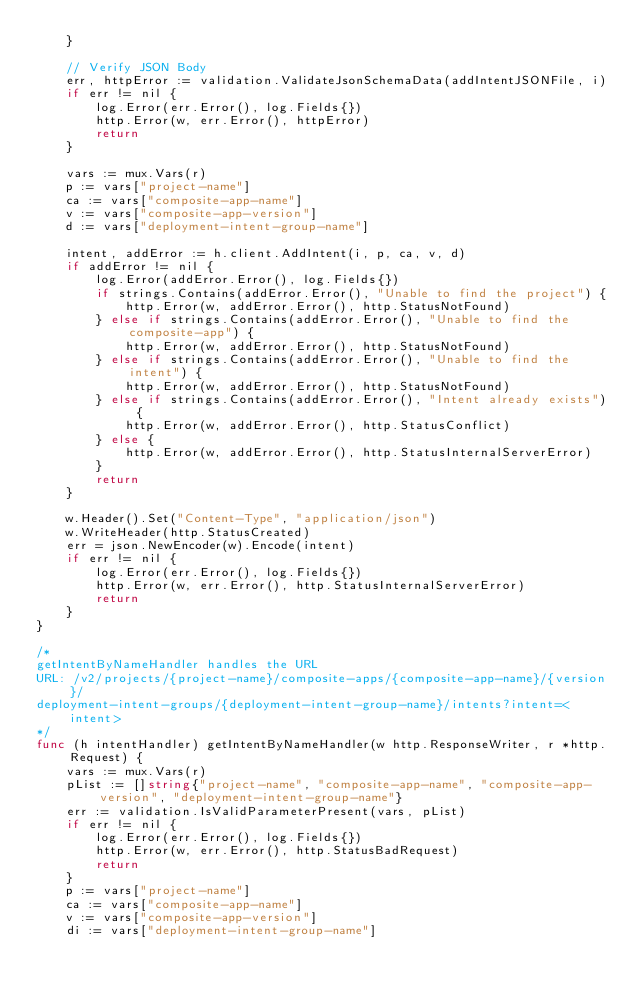<code> <loc_0><loc_0><loc_500><loc_500><_Go_>	}

	// Verify JSON Body
	err, httpError := validation.ValidateJsonSchemaData(addIntentJSONFile, i)
	if err != nil {
		log.Error(err.Error(), log.Fields{})
		http.Error(w, err.Error(), httpError)
		return
	}

	vars := mux.Vars(r)
	p := vars["project-name"]
	ca := vars["composite-app-name"]
	v := vars["composite-app-version"]
	d := vars["deployment-intent-group-name"]

	intent, addError := h.client.AddIntent(i, p, ca, v, d)
	if addError != nil {
		log.Error(addError.Error(), log.Fields{})
		if strings.Contains(addError.Error(), "Unable to find the project") {
			http.Error(w, addError.Error(), http.StatusNotFound)
		} else if strings.Contains(addError.Error(), "Unable to find the composite-app") {
			http.Error(w, addError.Error(), http.StatusNotFound)
		} else if strings.Contains(addError.Error(), "Unable to find the intent") {
			http.Error(w, addError.Error(), http.StatusNotFound)
		} else if strings.Contains(addError.Error(), "Intent already exists") {
			http.Error(w, addError.Error(), http.StatusConflict)
		} else {
			http.Error(w, addError.Error(), http.StatusInternalServerError)
		}
		return
	}

	w.Header().Set("Content-Type", "application/json")
	w.WriteHeader(http.StatusCreated)
	err = json.NewEncoder(w).Encode(intent)
	if err != nil {
		log.Error(err.Error(), log.Fields{})
		http.Error(w, err.Error(), http.StatusInternalServerError)
		return
	}
}

/*
getIntentByNameHandler handles the URL
URL: /v2/projects/{project-name}/composite-apps/{composite-app-name}/{version}/
deployment-intent-groups/{deployment-intent-group-name}/intents?intent=<intent>
*/
func (h intentHandler) getIntentByNameHandler(w http.ResponseWriter, r *http.Request) {
	vars := mux.Vars(r)
	pList := []string{"project-name", "composite-app-name", "composite-app-version", "deployment-intent-group-name"}
	err := validation.IsValidParameterPresent(vars, pList)
	if err != nil {
		log.Error(err.Error(), log.Fields{})
		http.Error(w, err.Error(), http.StatusBadRequest)
		return
	}
	p := vars["project-name"]
	ca := vars["composite-app-name"]
	v := vars["composite-app-version"]
	di := vars["deployment-intent-group-name"]
</code> 